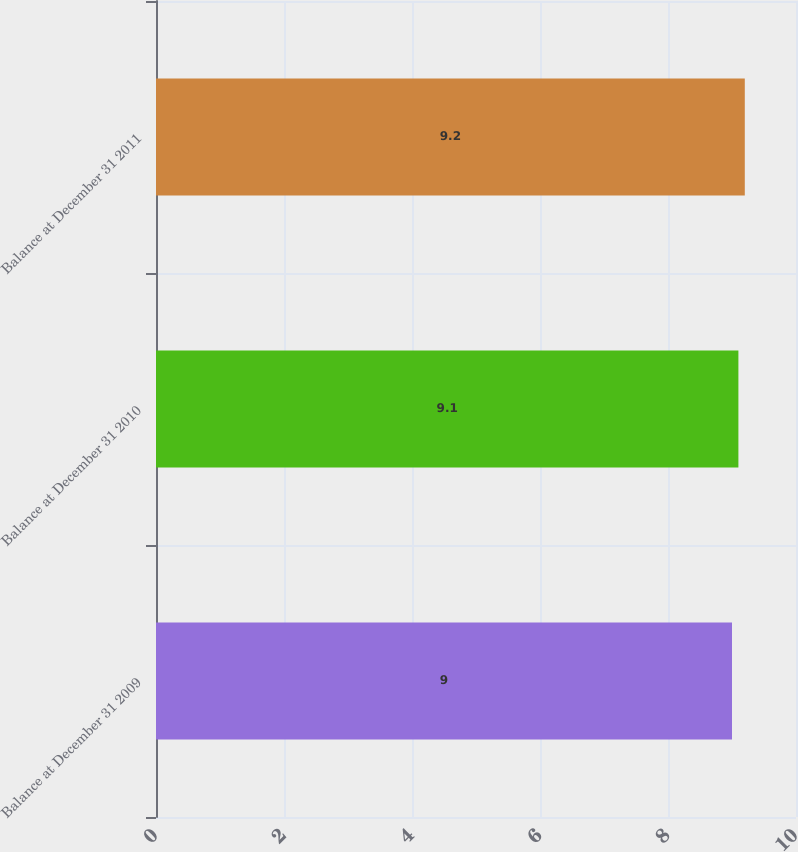Convert chart. <chart><loc_0><loc_0><loc_500><loc_500><bar_chart><fcel>Balance at December 31 2009<fcel>Balance at December 31 2010<fcel>Balance at December 31 2011<nl><fcel>9<fcel>9.1<fcel>9.2<nl></chart> 